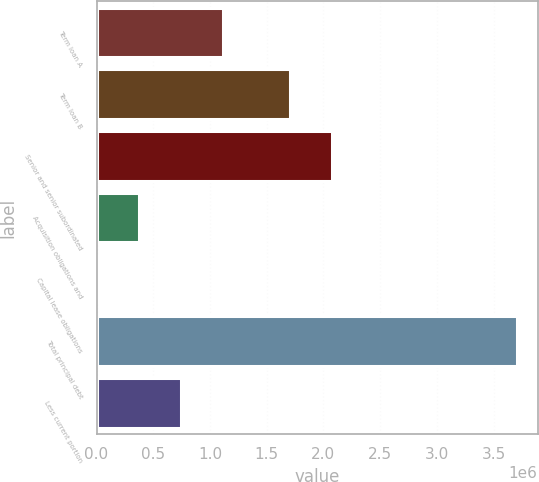Convert chart. <chart><loc_0><loc_0><loc_500><loc_500><bar_chart><fcel>Term loan A<fcel>Term loan B<fcel>Senior and senior subordinated<fcel>Acquisition obligations and<fcel>Capital lease obligations<fcel>Total principal debt<fcel>Less current portion<nl><fcel>1.11552e+06<fcel>1.70588e+06<fcel>2.07549e+06<fcel>376284<fcel>6667<fcel>3.70284e+06<fcel>745901<nl></chart> 